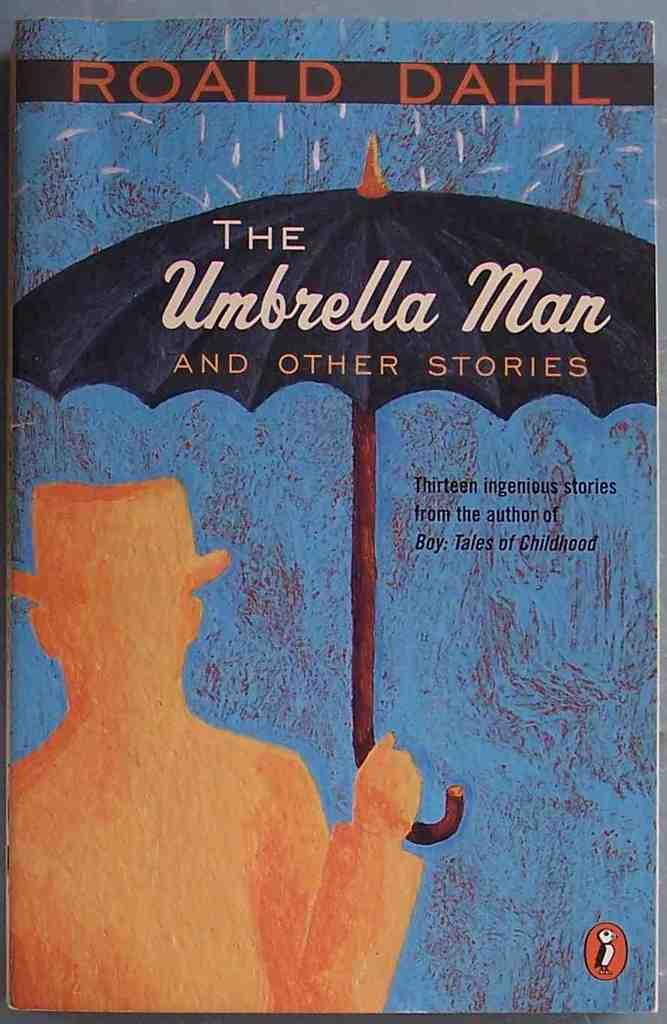<image>
Create a compact narrative representing the image presented. A book called The Umbrella Man by Roald Dahl. 